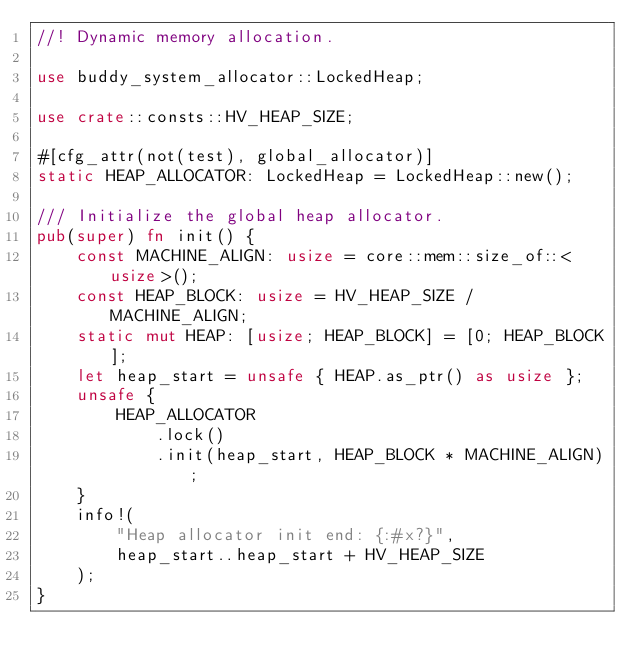Convert code to text. <code><loc_0><loc_0><loc_500><loc_500><_Rust_>//! Dynamic memory allocation.

use buddy_system_allocator::LockedHeap;

use crate::consts::HV_HEAP_SIZE;

#[cfg_attr(not(test), global_allocator)]
static HEAP_ALLOCATOR: LockedHeap = LockedHeap::new();

/// Initialize the global heap allocator.
pub(super) fn init() {
    const MACHINE_ALIGN: usize = core::mem::size_of::<usize>();
    const HEAP_BLOCK: usize = HV_HEAP_SIZE / MACHINE_ALIGN;
    static mut HEAP: [usize; HEAP_BLOCK] = [0; HEAP_BLOCK];
    let heap_start = unsafe { HEAP.as_ptr() as usize };
    unsafe {
        HEAP_ALLOCATOR
            .lock()
            .init(heap_start, HEAP_BLOCK * MACHINE_ALIGN);
    }
    info!(
        "Heap allocator init end: {:#x?}",
        heap_start..heap_start + HV_HEAP_SIZE
    );
}
</code> 